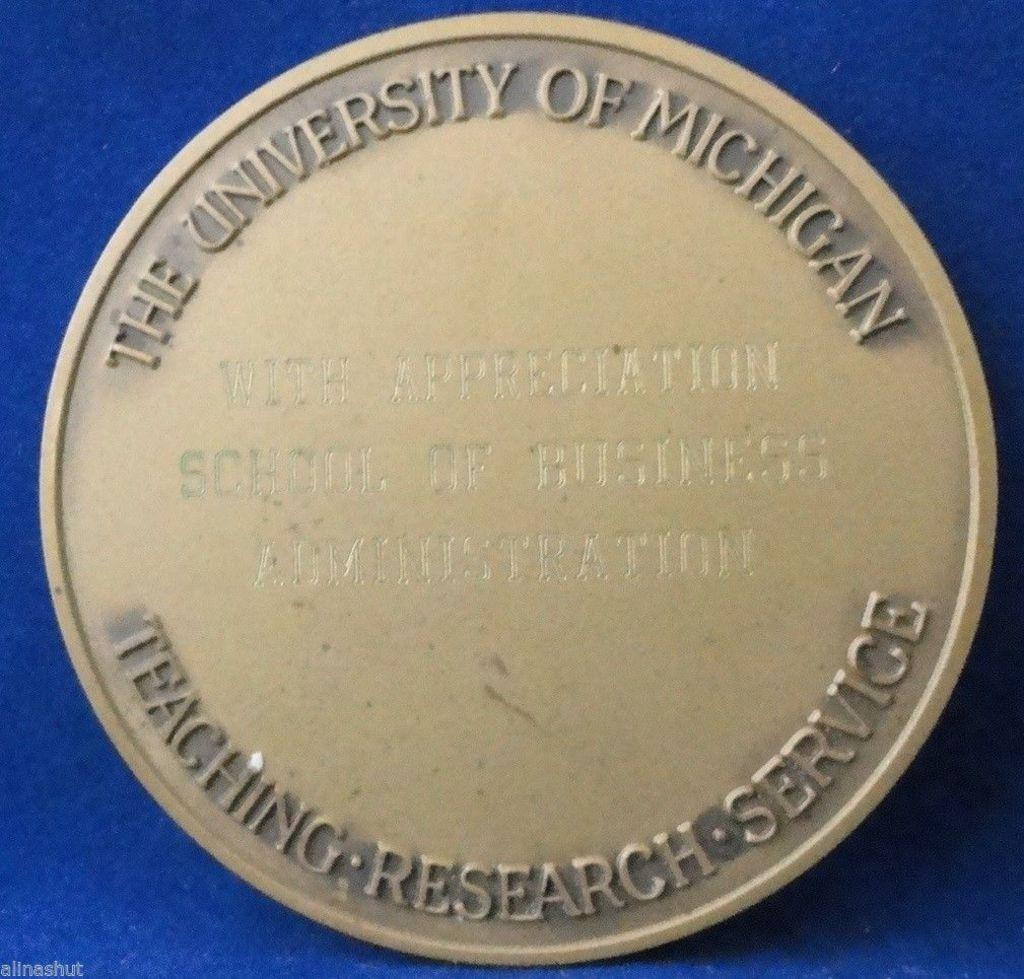What is the shape of the main object in the image? The main object in the image is round shaped. What is the color of the surface on which the round shaped object is placed? The round shaped object is on a blue color surface. Can you describe any text or symbols on the round shaped object? Yes, there is writing on the round shaped object. How many grapes are hanging from the dress in the image? There is no dress or grapes present in the image. What type of cherries are visible on the round shaped object in the image? There are no cherries present on the round shaped object in the image. 